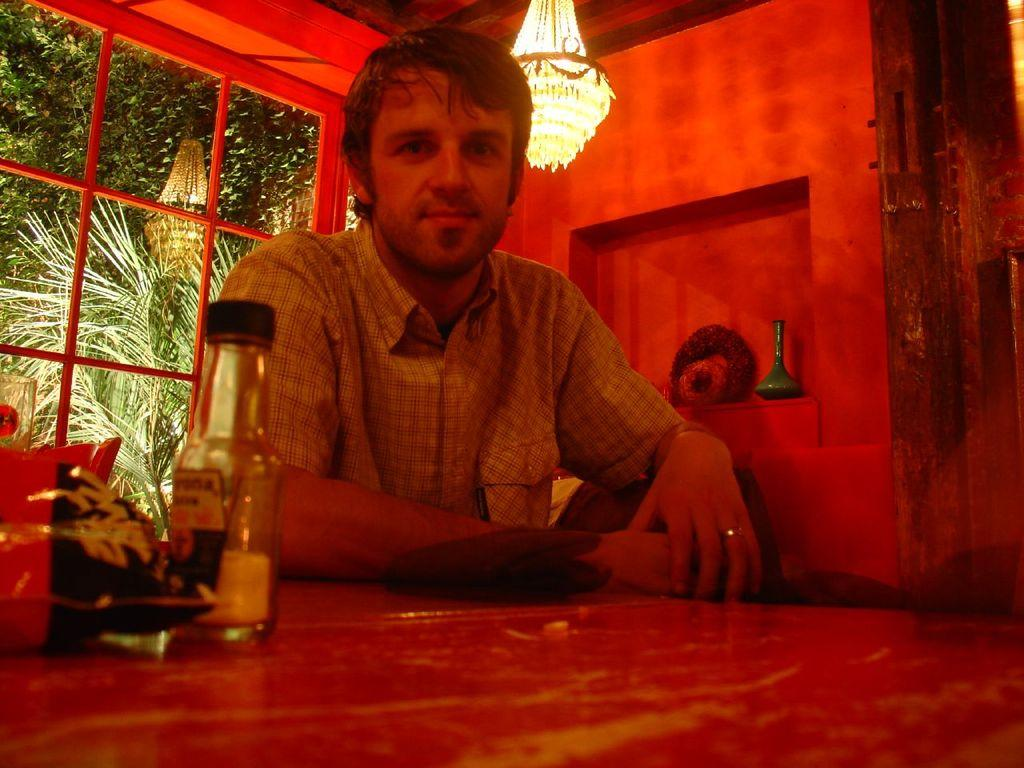What is the person in the image doing? The person is sitting in the image. What is in front of the person? The person has a table in front of them. What items can be seen on the table? There is a packet and a bottle on the table. What can be seen in the background of the image? There is a wall, lights, and a window in the background of the image. What type of cart can be seen in the image? There is no cart present in the image. Can you tell me how many animals from the zoo are visible in the image? There are no animals from the zoo present in the image. 